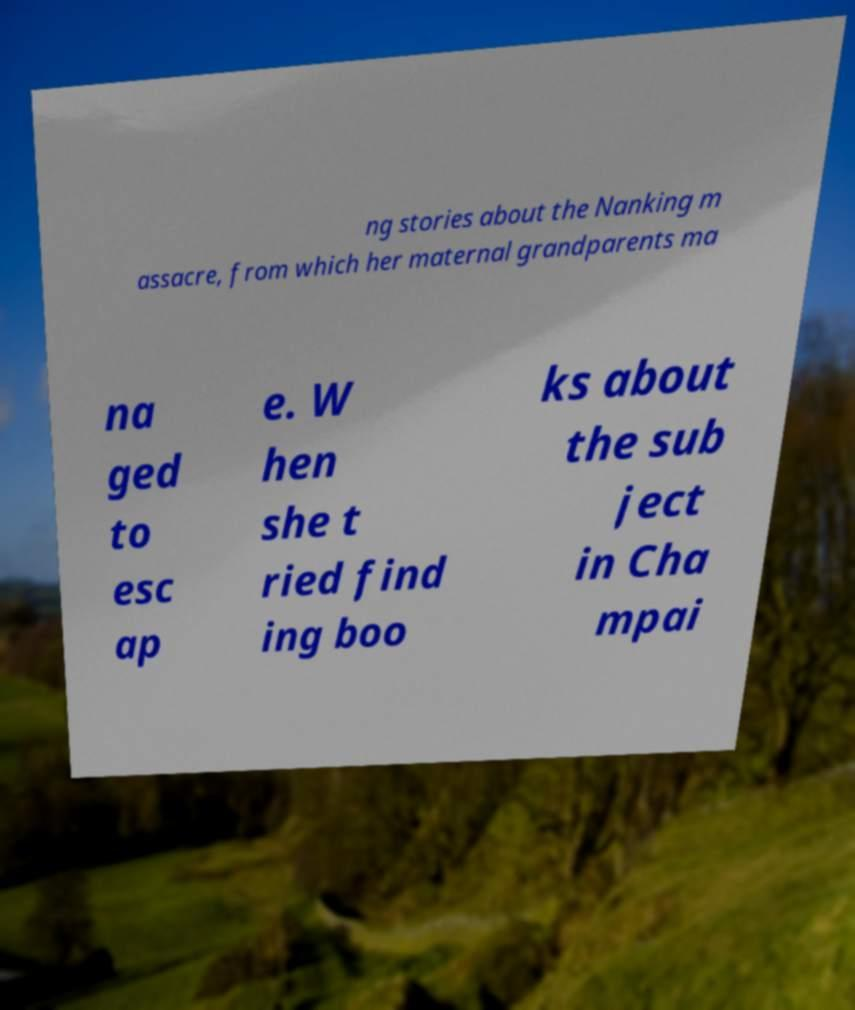Can you accurately transcribe the text from the provided image for me? ng stories about the Nanking m assacre, from which her maternal grandparents ma na ged to esc ap e. W hen she t ried find ing boo ks about the sub ject in Cha mpai 